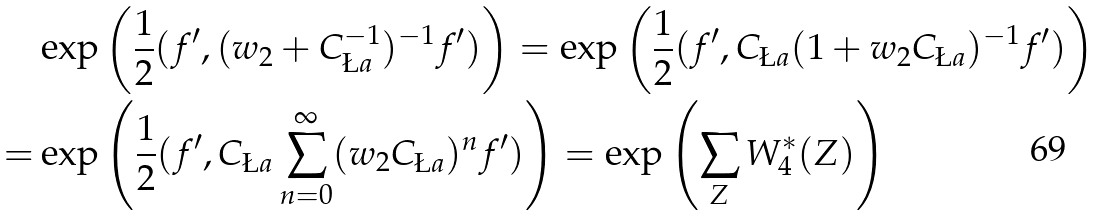<formula> <loc_0><loc_0><loc_500><loc_500>& \exp \left ( \frac { 1 } { 2 } ( f ^ { \prime } , ( w _ { 2 } + C _ { \L a } ^ { - 1 } ) ^ { - 1 } f ^ { \prime } ) \right ) = \exp \left ( \frac { 1 } { 2 } ( f ^ { \prime } , C _ { \L a } ( 1 + w _ { 2 } C _ { \L a } ) ^ { - 1 } f ^ { \prime } ) \right ) \\ = & \exp \left ( \frac { 1 } { 2 } ( f ^ { \prime } , C _ { \L a } \sum _ { n = 0 } ^ { \infty } ( w _ { 2 } C _ { \L a } ) ^ { n } f ^ { \prime } ) \right ) = \exp \left ( \sum _ { Z } W _ { 4 } ^ { * } ( Z ) \right ) \\</formula> 